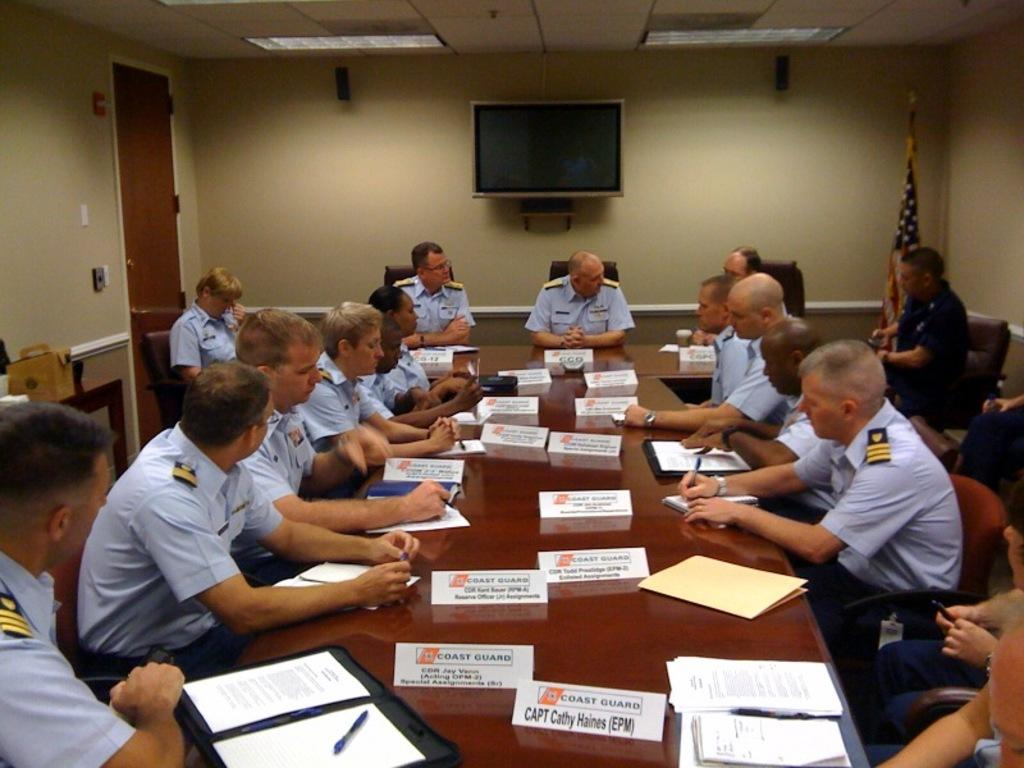<image>
Describe the image concisely. Several members of the Coast Guard are sitting around a table. 